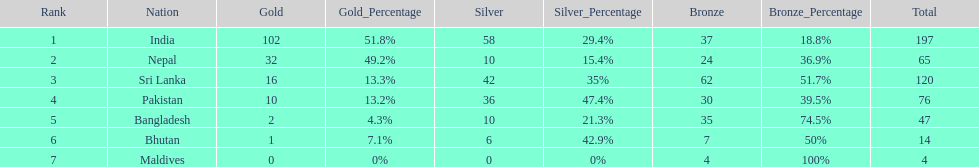What is the difference between the nation with the most medals and the nation with the least amount of medals? 193. 